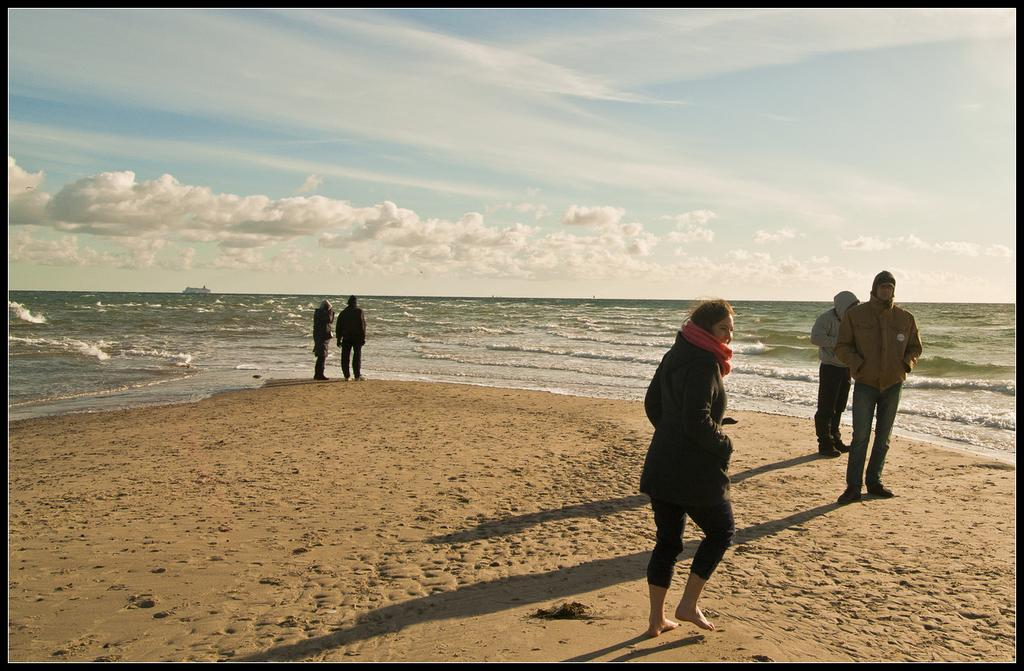What type of natural environment is depicted in the image? There is a sea in the image. What are the people doing in the image? The people are standing on the sand in front of the sea and enjoying the view. What type of letter can be seen floating in the sea in the image? There is no letter visible in the sea in the image. Are there any bees or clovers present in the image? No, there are no bees or clovers present in the image. 